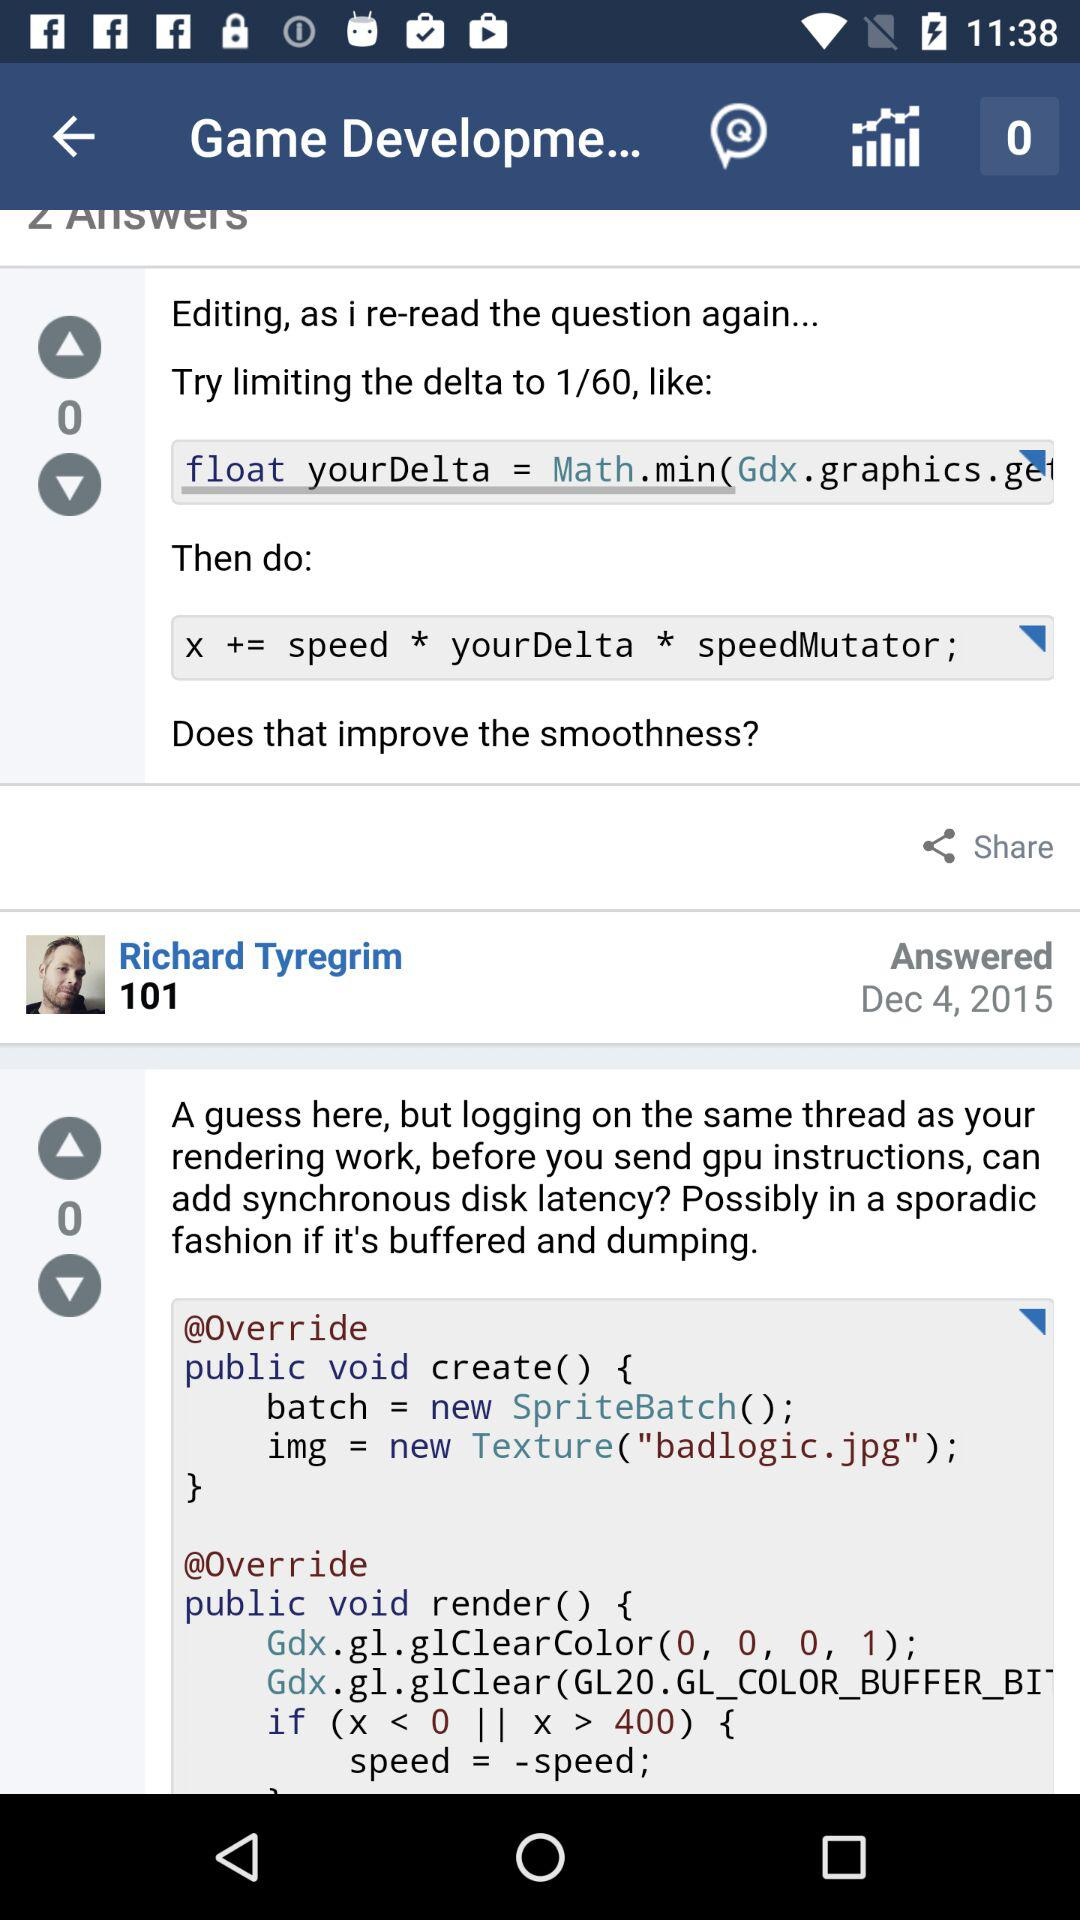How many comments are there on this post?
Answer the question using a single word or phrase. 2 